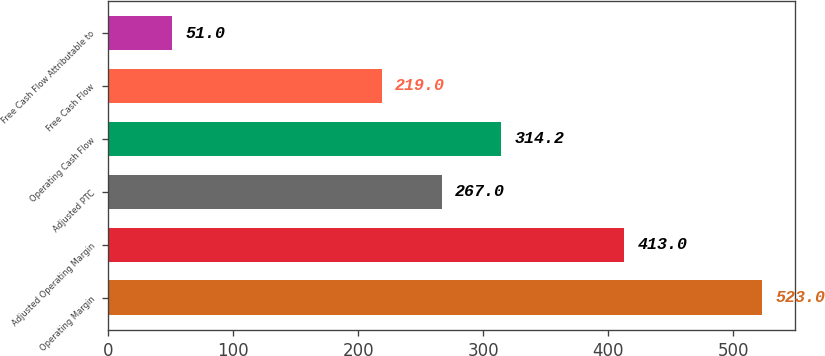Convert chart to OTSL. <chart><loc_0><loc_0><loc_500><loc_500><bar_chart><fcel>Operating Margin<fcel>Adjusted Operating Margin<fcel>Adjusted PTC<fcel>Operating Cash Flow<fcel>Free Cash Flow<fcel>Free Cash Flow Attributable to<nl><fcel>523<fcel>413<fcel>267<fcel>314.2<fcel>219<fcel>51<nl></chart> 